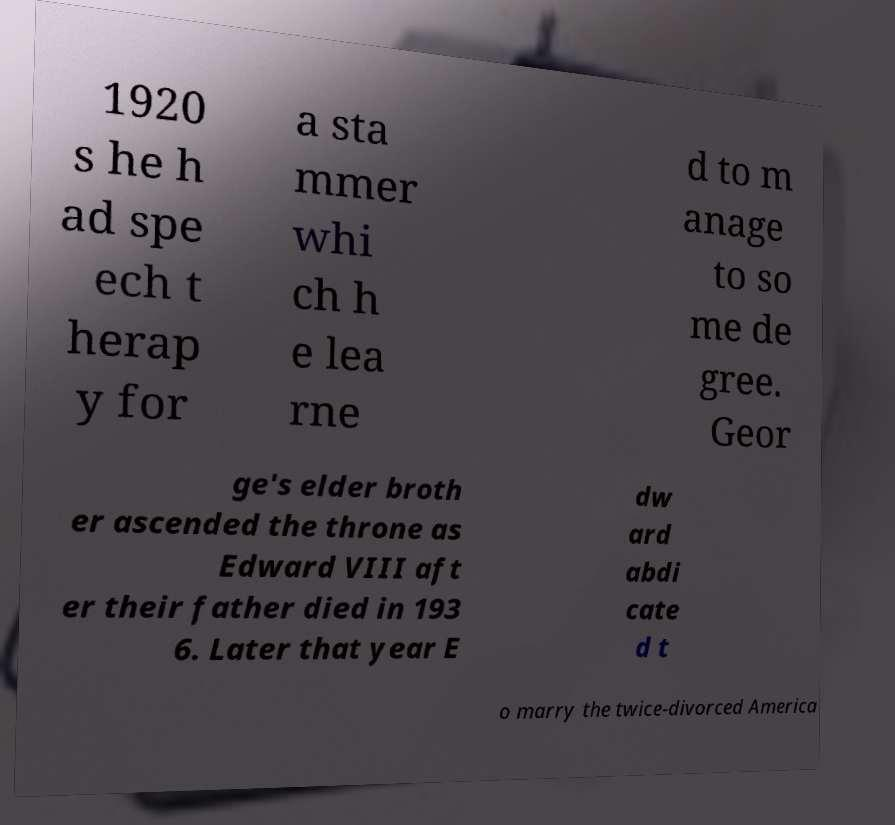Please identify and transcribe the text found in this image. 1920 s he h ad spe ech t herap y for a sta mmer whi ch h e lea rne d to m anage to so me de gree. Geor ge's elder broth er ascended the throne as Edward VIII aft er their father died in 193 6. Later that year E dw ard abdi cate d t o marry the twice-divorced America 